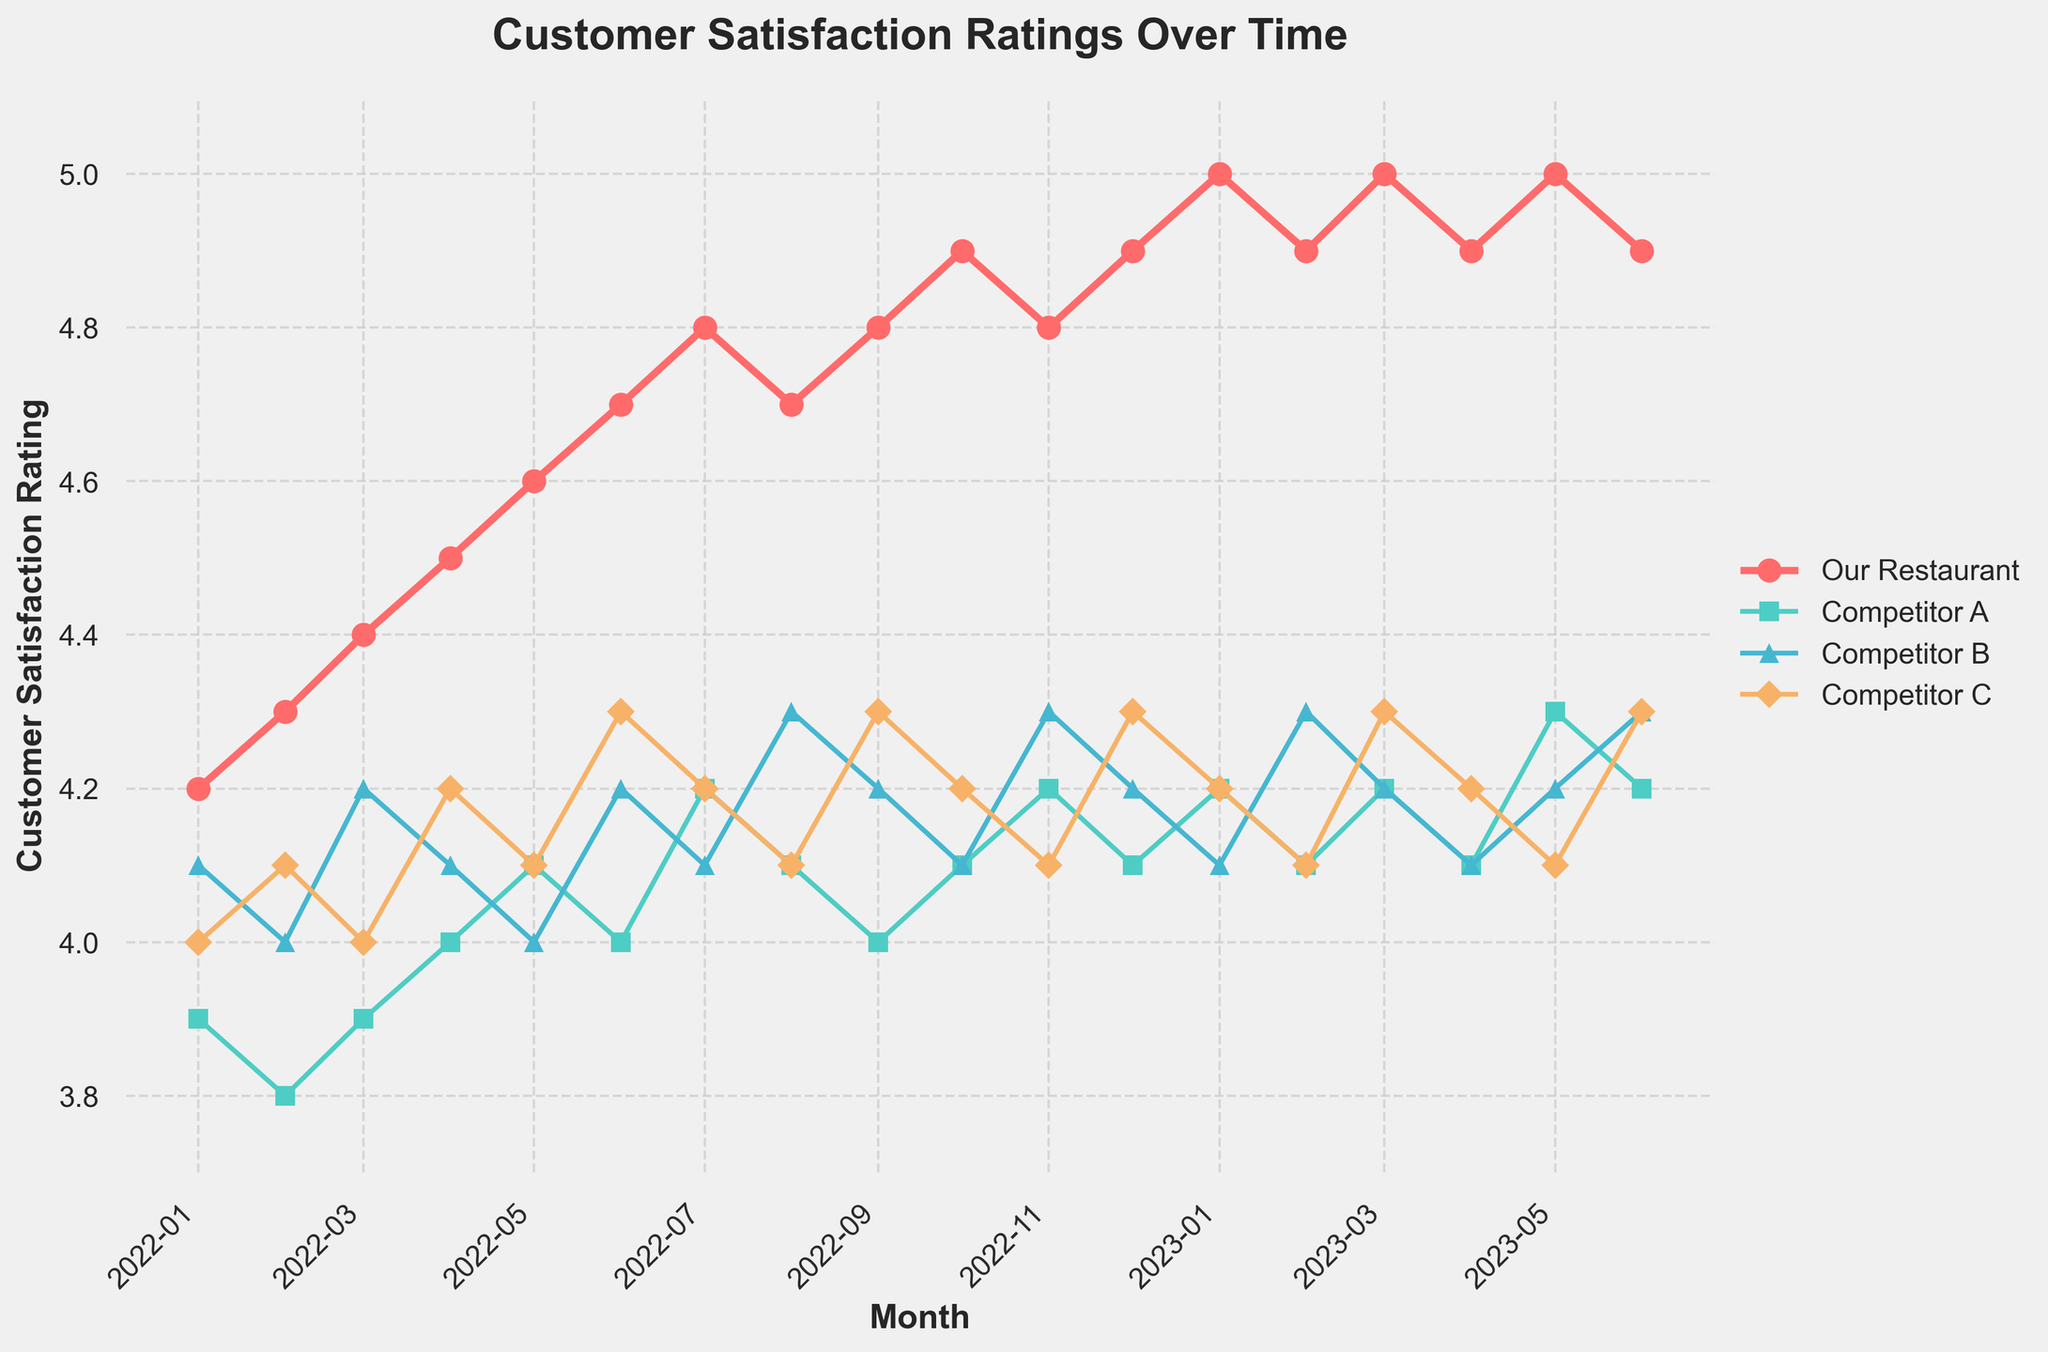What is the trend of customer satisfaction ratings for our restaurant from January 2022 to June 2023? The trend for our restaurant shows a general increase in customer satisfaction ratings from January 2022 (4.2) to June 2023 (4.9), with some small fluctuations.
Answer: Increasing trend How does our restaurant's customer satisfaction rating in June 2023 compare to Competitor A's rating in the same month? In June 2023, our restaurant has a customer satisfaction rating of 4.9, whereas Competitor A has a rating of 4.2. Our restaurant's rating is higher by 0.7 points.
Answer: Higher by 0.7 points Which month shows the highest customer satisfaction rating for Competitor B, and what is that rating? The highest customer satisfaction rating for Competitor B is in November 2022 with a rating of 4.3.
Answer: November 2022, 4.3 Is there any month where our restaurant's rating equals Competitor C's rating? If so, which month(s) and what is the rating? Yes, in June 2023, both our restaurant and Competitor C have a customer satisfaction rating of 4.9.
Answer: June 2023, 4.9 Calculate the average customer satisfaction rating for Competitor A over the entire period shown. Summing up Competitor A's ratings (3.9+3.8+3.9+4.0+4.1+4.0+4.2+4.1+4.0+4.1+4.2+4.1+4.2+4.1+4.2+4.3+4.2) equals 69.6. Dividing by the number of months (17), the average is approximately 4.09.
Answer: Approximately 4.09 How does the fluctuation in customer satisfaction ratings for Competitor C compare to our restaurant's over the whole period? Competitor C's ratings have small fluctuations between 4.0 and 4.3. Our restaurant's ratings fluctuate more significantly from 4.2 to 5.0, showing a clearer upward trend.
Answer: Our restaurant fluctuates more and has a clearer upward trend Which competitor had the most stable customer satisfaction rating throughout the period and how can you tell? Competitor C had the most stable ratings, with values consistently between 4.0 and 4.3. This is evidenced by the narrow range of their ratings compared to the other competitors.
Answer: Competitor C, narrow range of 4.0-4.3 What is the difference in customer satisfaction ratings between our restaurant and Competitor B in July 2022? In July 2022, our restaurant's rating is 4.8 and Competitor B's rating is 4.1. The difference is 0.7 points.
Answer: 0.7 points Which month shows the most considerable increase in our restaurant's customer satisfaction rating compared to the previous month? January 2023 shows the most significant increase in our satisfaction rating compared to December 2022, with an increase from 4.9 to 5.0, an increase of 0.1 points.
Answer: January 2023, 0.1 points 